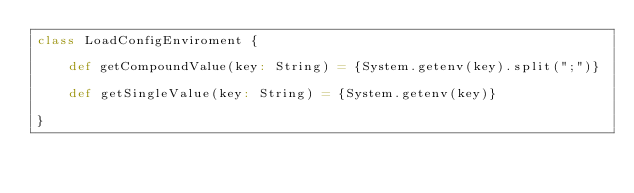Convert code to text. <code><loc_0><loc_0><loc_500><loc_500><_Scala_>class LoadConfigEnviroment {

    def getCompoundValue(key: String) = {System.getenv(key).split(";")}

    def getSingleValue(key: String) = {System.getenv(key)}

}
</code> 